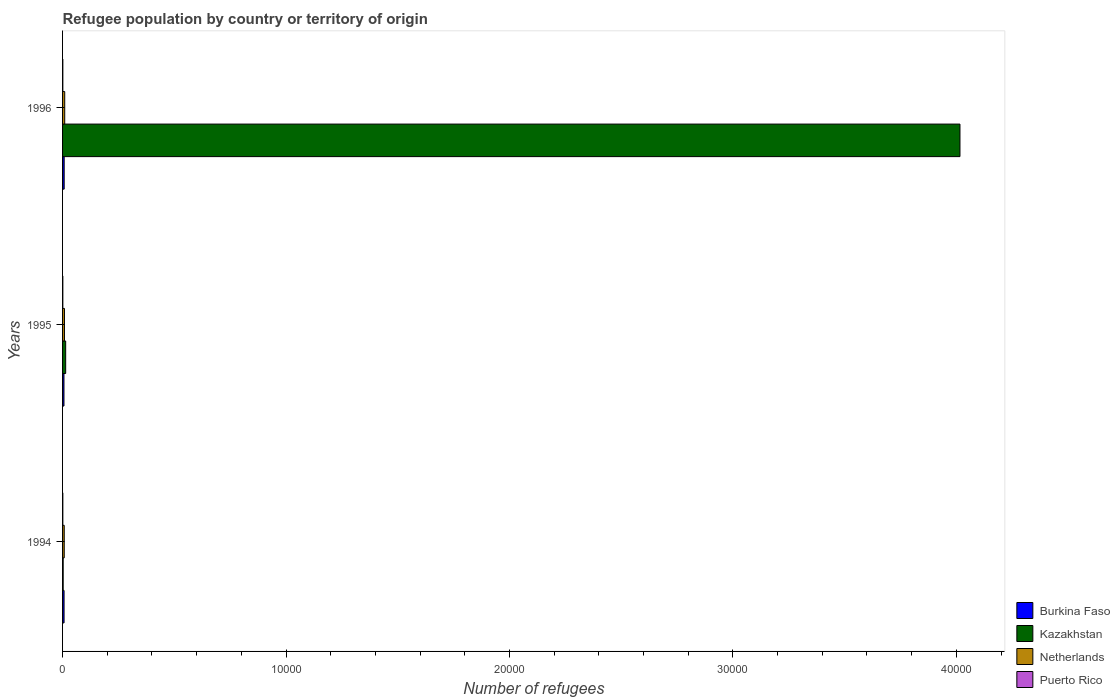How many groups of bars are there?
Your answer should be compact. 3. Are the number of bars per tick equal to the number of legend labels?
Your answer should be very brief. Yes. How many bars are there on the 1st tick from the bottom?
Your answer should be very brief. 4. What is the label of the 2nd group of bars from the top?
Your response must be concise. 1995. What is the number of refugees in Burkina Faso in 1995?
Give a very brief answer. 63. Across all years, what is the maximum number of refugees in Netherlands?
Provide a short and direct response. 96. Across all years, what is the minimum number of refugees in Netherlands?
Provide a short and direct response. 75. In which year was the number of refugees in Kazakhstan maximum?
Your answer should be compact. 1996. In which year was the number of refugees in Puerto Rico minimum?
Give a very brief answer. 1994. What is the total number of refugees in Burkina Faso in the graph?
Provide a succinct answer. 202. What is the difference between the number of refugees in Netherlands in 1994 and that in 1996?
Keep it short and to the point. -21. What is the difference between the number of refugees in Puerto Rico in 1994 and the number of refugees in Burkina Faso in 1995?
Provide a succinct answer. -51. What is the average number of refugees in Netherlands per year?
Your response must be concise. 85.33. In the year 1995, what is the difference between the number of refugees in Kazakhstan and number of refugees in Puerto Rico?
Your answer should be compact. 127. In how many years, is the number of refugees in Netherlands greater than 26000 ?
Keep it short and to the point. 0. What is the ratio of the number of refugees in Kazakhstan in 1994 to that in 1995?
Offer a very short reply. 0.19. Is the number of refugees in Kazakhstan in 1994 less than that in 1996?
Provide a short and direct response. Yes. Is the difference between the number of refugees in Kazakhstan in 1994 and 1996 greater than the difference between the number of refugees in Puerto Rico in 1994 and 1996?
Provide a short and direct response. No. What is the difference between the highest and the second highest number of refugees in Netherlands?
Provide a succinct answer. 11. What is the difference between the highest and the lowest number of refugees in Kazakhstan?
Offer a very short reply. 4.01e+04. In how many years, is the number of refugees in Puerto Rico greater than the average number of refugees in Puerto Rico taken over all years?
Provide a succinct answer. 0. Is the sum of the number of refugees in Puerto Rico in 1994 and 1995 greater than the maximum number of refugees in Netherlands across all years?
Your answer should be compact. No. What does the 1st bar from the bottom in 1996 represents?
Keep it short and to the point. Burkina Faso. Is it the case that in every year, the sum of the number of refugees in Kazakhstan and number of refugees in Puerto Rico is greater than the number of refugees in Burkina Faso?
Ensure brevity in your answer.  No. Are all the bars in the graph horizontal?
Your answer should be very brief. Yes. How many years are there in the graph?
Provide a succinct answer. 3. What is the difference between two consecutive major ticks on the X-axis?
Ensure brevity in your answer.  10000. Are the values on the major ticks of X-axis written in scientific E-notation?
Give a very brief answer. No. Where does the legend appear in the graph?
Ensure brevity in your answer.  Bottom right. How many legend labels are there?
Keep it short and to the point. 4. How are the legend labels stacked?
Offer a very short reply. Vertical. What is the title of the graph?
Your response must be concise. Refugee population by country or territory of origin. What is the label or title of the X-axis?
Provide a short and direct response. Number of refugees. What is the label or title of the Y-axis?
Provide a short and direct response. Years. What is the Number of refugees in Burkina Faso in 1994?
Offer a very short reply. 67. What is the Number of refugees of Puerto Rico in 1994?
Offer a terse response. 12. What is the Number of refugees in Burkina Faso in 1995?
Your answer should be very brief. 63. What is the Number of refugees of Kazakhstan in 1995?
Offer a terse response. 139. What is the Number of refugees of Puerto Rico in 1995?
Offer a terse response. 12. What is the Number of refugees of Burkina Faso in 1996?
Offer a very short reply. 72. What is the Number of refugees in Kazakhstan in 1996?
Offer a very short reply. 4.02e+04. What is the Number of refugees of Netherlands in 1996?
Ensure brevity in your answer.  96. Across all years, what is the maximum Number of refugees of Burkina Faso?
Your response must be concise. 72. Across all years, what is the maximum Number of refugees of Kazakhstan?
Your response must be concise. 4.02e+04. Across all years, what is the maximum Number of refugees in Netherlands?
Your answer should be very brief. 96. Across all years, what is the maximum Number of refugees in Puerto Rico?
Your answer should be very brief. 12. Across all years, what is the minimum Number of refugees in Burkina Faso?
Provide a short and direct response. 63. Across all years, what is the minimum Number of refugees in Kazakhstan?
Keep it short and to the point. 27. Across all years, what is the minimum Number of refugees of Netherlands?
Your answer should be compact. 75. Across all years, what is the minimum Number of refugees of Puerto Rico?
Provide a succinct answer. 12. What is the total Number of refugees of Burkina Faso in the graph?
Give a very brief answer. 202. What is the total Number of refugees of Kazakhstan in the graph?
Ensure brevity in your answer.  4.03e+04. What is the total Number of refugees of Netherlands in the graph?
Offer a terse response. 256. What is the total Number of refugees in Puerto Rico in the graph?
Provide a short and direct response. 36. What is the difference between the Number of refugees of Burkina Faso in 1994 and that in 1995?
Make the answer very short. 4. What is the difference between the Number of refugees of Kazakhstan in 1994 and that in 1995?
Offer a very short reply. -112. What is the difference between the Number of refugees in Kazakhstan in 1994 and that in 1996?
Your answer should be very brief. -4.01e+04. What is the difference between the Number of refugees in Netherlands in 1994 and that in 1996?
Provide a short and direct response. -21. What is the difference between the Number of refugees of Kazakhstan in 1995 and that in 1996?
Ensure brevity in your answer.  -4.00e+04. What is the difference between the Number of refugees in Burkina Faso in 1994 and the Number of refugees in Kazakhstan in 1995?
Your response must be concise. -72. What is the difference between the Number of refugees in Burkina Faso in 1994 and the Number of refugees in Netherlands in 1995?
Provide a succinct answer. -18. What is the difference between the Number of refugees of Burkina Faso in 1994 and the Number of refugees of Puerto Rico in 1995?
Keep it short and to the point. 55. What is the difference between the Number of refugees in Kazakhstan in 1994 and the Number of refugees in Netherlands in 1995?
Provide a succinct answer. -58. What is the difference between the Number of refugees of Kazakhstan in 1994 and the Number of refugees of Puerto Rico in 1995?
Provide a succinct answer. 15. What is the difference between the Number of refugees in Burkina Faso in 1994 and the Number of refugees in Kazakhstan in 1996?
Your answer should be compact. -4.01e+04. What is the difference between the Number of refugees of Burkina Faso in 1994 and the Number of refugees of Netherlands in 1996?
Your answer should be very brief. -29. What is the difference between the Number of refugees in Burkina Faso in 1994 and the Number of refugees in Puerto Rico in 1996?
Your answer should be compact. 55. What is the difference between the Number of refugees of Kazakhstan in 1994 and the Number of refugees of Netherlands in 1996?
Provide a succinct answer. -69. What is the difference between the Number of refugees of Kazakhstan in 1994 and the Number of refugees of Puerto Rico in 1996?
Your answer should be compact. 15. What is the difference between the Number of refugees in Burkina Faso in 1995 and the Number of refugees in Kazakhstan in 1996?
Offer a terse response. -4.01e+04. What is the difference between the Number of refugees of Burkina Faso in 1995 and the Number of refugees of Netherlands in 1996?
Provide a succinct answer. -33. What is the difference between the Number of refugees in Burkina Faso in 1995 and the Number of refugees in Puerto Rico in 1996?
Offer a very short reply. 51. What is the difference between the Number of refugees in Kazakhstan in 1995 and the Number of refugees in Netherlands in 1996?
Keep it short and to the point. 43. What is the difference between the Number of refugees of Kazakhstan in 1995 and the Number of refugees of Puerto Rico in 1996?
Provide a succinct answer. 127. What is the average Number of refugees in Burkina Faso per year?
Your answer should be compact. 67.33. What is the average Number of refugees in Kazakhstan per year?
Keep it short and to the point. 1.34e+04. What is the average Number of refugees in Netherlands per year?
Offer a terse response. 85.33. What is the average Number of refugees of Puerto Rico per year?
Your response must be concise. 12. In the year 1994, what is the difference between the Number of refugees of Burkina Faso and Number of refugees of Puerto Rico?
Provide a succinct answer. 55. In the year 1994, what is the difference between the Number of refugees of Kazakhstan and Number of refugees of Netherlands?
Your answer should be compact. -48. In the year 1994, what is the difference between the Number of refugees in Kazakhstan and Number of refugees in Puerto Rico?
Your answer should be compact. 15. In the year 1995, what is the difference between the Number of refugees of Burkina Faso and Number of refugees of Kazakhstan?
Provide a short and direct response. -76. In the year 1995, what is the difference between the Number of refugees in Burkina Faso and Number of refugees in Netherlands?
Your answer should be very brief. -22. In the year 1995, what is the difference between the Number of refugees in Burkina Faso and Number of refugees in Puerto Rico?
Ensure brevity in your answer.  51. In the year 1995, what is the difference between the Number of refugees in Kazakhstan and Number of refugees in Puerto Rico?
Your response must be concise. 127. In the year 1995, what is the difference between the Number of refugees in Netherlands and Number of refugees in Puerto Rico?
Ensure brevity in your answer.  73. In the year 1996, what is the difference between the Number of refugees in Burkina Faso and Number of refugees in Kazakhstan?
Your answer should be compact. -4.01e+04. In the year 1996, what is the difference between the Number of refugees in Burkina Faso and Number of refugees in Puerto Rico?
Keep it short and to the point. 60. In the year 1996, what is the difference between the Number of refugees in Kazakhstan and Number of refugees in Netherlands?
Your response must be concise. 4.01e+04. In the year 1996, what is the difference between the Number of refugees of Kazakhstan and Number of refugees of Puerto Rico?
Offer a terse response. 4.02e+04. What is the ratio of the Number of refugees in Burkina Faso in 1994 to that in 1995?
Offer a terse response. 1.06. What is the ratio of the Number of refugees of Kazakhstan in 1994 to that in 1995?
Make the answer very short. 0.19. What is the ratio of the Number of refugees in Netherlands in 1994 to that in 1995?
Ensure brevity in your answer.  0.88. What is the ratio of the Number of refugees of Burkina Faso in 1994 to that in 1996?
Provide a short and direct response. 0.93. What is the ratio of the Number of refugees of Kazakhstan in 1994 to that in 1996?
Keep it short and to the point. 0. What is the ratio of the Number of refugees of Netherlands in 1994 to that in 1996?
Your answer should be very brief. 0.78. What is the ratio of the Number of refugees of Puerto Rico in 1994 to that in 1996?
Keep it short and to the point. 1. What is the ratio of the Number of refugees of Kazakhstan in 1995 to that in 1996?
Offer a very short reply. 0. What is the ratio of the Number of refugees in Netherlands in 1995 to that in 1996?
Make the answer very short. 0.89. What is the ratio of the Number of refugees of Puerto Rico in 1995 to that in 1996?
Offer a terse response. 1. What is the difference between the highest and the second highest Number of refugees in Burkina Faso?
Make the answer very short. 5. What is the difference between the highest and the second highest Number of refugees in Kazakhstan?
Ensure brevity in your answer.  4.00e+04. What is the difference between the highest and the second highest Number of refugees in Netherlands?
Keep it short and to the point. 11. What is the difference between the highest and the second highest Number of refugees in Puerto Rico?
Keep it short and to the point. 0. What is the difference between the highest and the lowest Number of refugees in Burkina Faso?
Give a very brief answer. 9. What is the difference between the highest and the lowest Number of refugees in Kazakhstan?
Keep it short and to the point. 4.01e+04. What is the difference between the highest and the lowest Number of refugees in Netherlands?
Keep it short and to the point. 21. What is the difference between the highest and the lowest Number of refugees in Puerto Rico?
Ensure brevity in your answer.  0. 